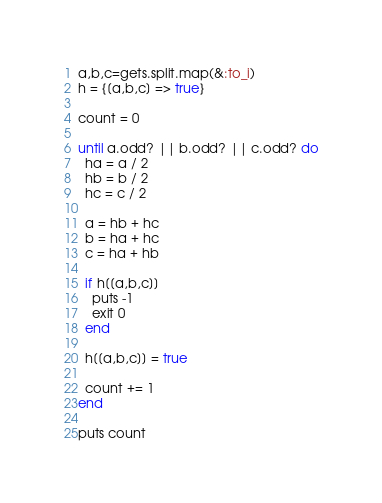Convert code to text. <code><loc_0><loc_0><loc_500><loc_500><_Ruby_>a,b,c=gets.split.map(&:to_i)
h = {[a,b,c] => true}

count = 0

until a.odd? || b.odd? || c.odd? do
  ha = a / 2
  hb = b / 2
  hc = c / 2

  a = hb + hc
  b = ha + hc
  c = ha + hb

  if h[[a,b,c]]
    puts -1
    exit 0
  end

  h[[a,b,c]] = true

  count += 1
end

puts count</code> 